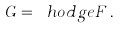Convert formula to latex. <formula><loc_0><loc_0><loc_500><loc_500>G = \ h o d g e F \, .</formula> 